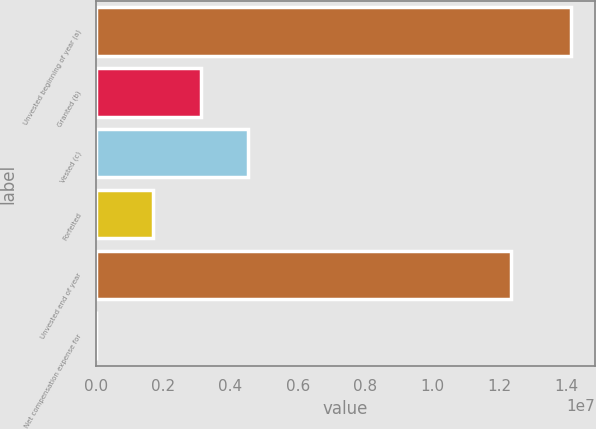Convert chart to OTSL. <chart><loc_0><loc_0><loc_500><loc_500><bar_chart><fcel>Unvested beginning of year (a)<fcel>Granted (b)<fcel>Vested (c)<fcel>Forfeited<fcel>Unvested end of year<fcel>Net compensation expense for<nl><fcel>1.41231e+07<fcel>3.12383e+06<fcel>4.53613e+06<fcel>1.71153e+06<fcel>1.23566e+07<fcel>84<nl></chart> 